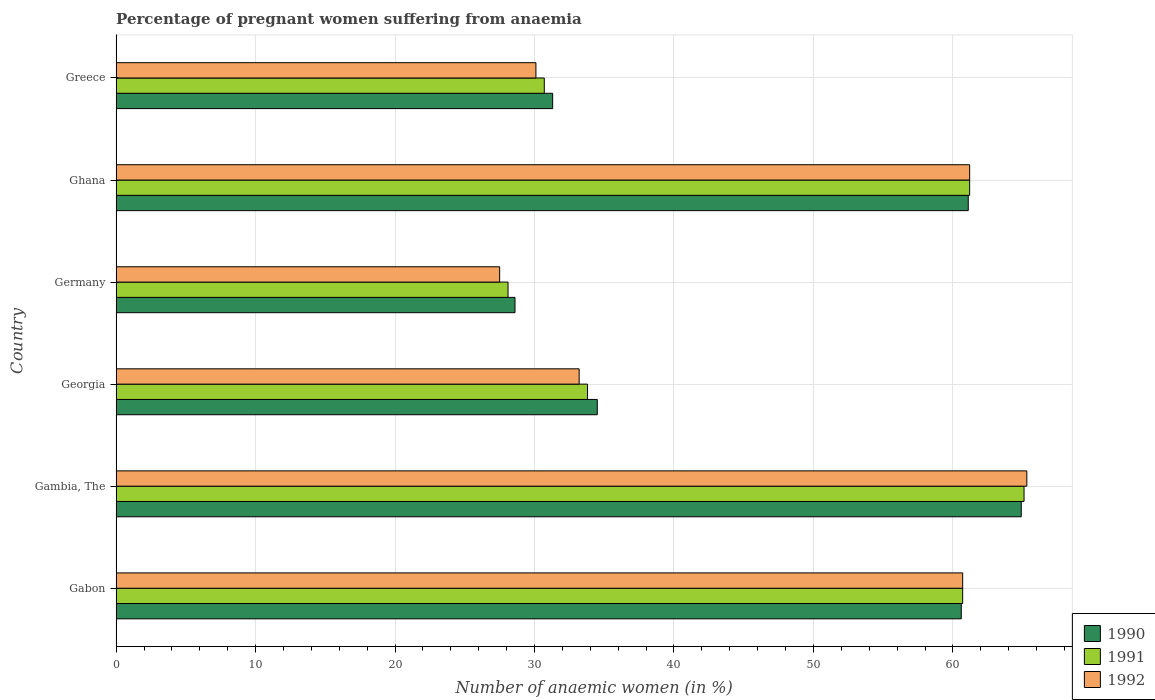Are the number of bars on each tick of the Y-axis equal?
Ensure brevity in your answer.  Yes. What is the label of the 1st group of bars from the top?
Provide a short and direct response. Greece. What is the number of anaemic women in 1991 in Georgia?
Keep it short and to the point. 33.8. Across all countries, what is the maximum number of anaemic women in 1991?
Offer a terse response. 65.1. In which country was the number of anaemic women in 1991 maximum?
Provide a short and direct response. Gambia, The. What is the total number of anaemic women in 1991 in the graph?
Your answer should be compact. 279.6. What is the difference between the number of anaemic women in 1991 in Germany and that in Ghana?
Ensure brevity in your answer.  -33.1. What is the difference between the number of anaemic women in 1992 in Greece and the number of anaemic women in 1991 in Gabon?
Offer a terse response. -30.6. What is the average number of anaemic women in 1991 per country?
Make the answer very short. 46.6. What is the difference between the number of anaemic women in 1992 and number of anaemic women in 1990 in Ghana?
Your answer should be very brief. 0.1. In how many countries, is the number of anaemic women in 1992 greater than 64 %?
Your response must be concise. 1. What is the ratio of the number of anaemic women in 1990 in Gambia, The to that in Greece?
Give a very brief answer. 2.07. Is the number of anaemic women in 1991 in Gabon less than that in Gambia, The?
Provide a succinct answer. Yes. Is the difference between the number of anaemic women in 1992 in Gambia, The and Georgia greater than the difference between the number of anaemic women in 1990 in Gambia, The and Georgia?
Your answer should be very brief. Yes. What is the difference between the highest and the second highest number of anaemic women in 1991?
Offer a very short reply. 3.9. What is the difference between the highest and the lowest number of anaemic women in 1992?
Keep it short and to the point. 37.8. How many bars are there?
Your response must be concise. 18. What is the difference between two consecutive major ticks on the X-axis?
Your response must be concise. 10. Does the graph contain any zero values?
Your answer should be very brief. No. How are the legend labels stacked?
Your answer should be very brief. Vertical. What is the title of the graph?
Give a very brief answer. Percentage of pregnant women suffering from anaemia. Does "1964" appear as one of the legend labels in the graph?
Give a very brief answer. No. What is the label or title of the X-axis?
Your answer should be very brief. Number of anaemic women (in %). What is the Number of anaemic women (in %) of 1990 in Gabon?
Your answer should be very brief. 60.6. What is the Number of anaemic women (in %) in 1991 in Gabon?
Make the answer very short. 60.7. What is the Number of anaemic women (in %) of 1992 in Gabon?
Provide a short and direct response. 60.7. What is the Number of anaemic women (in %) of 1990 in Gambia, The?
Your response must be concise. 64.9. What is the Number of anaemic women (in %) in 1991 in Gambia, The?
Offer a very short reply. 65.1. What is the Number of anaemic women (in %) of 1992 in Gambia, The?
Your response must be concise. 65.3. What is the Number of anaemic women (in %) of 1990 in Georgia?
Offer a terse response. 34.5. What is the Number of anaemic women (in %) of 1991 in Georgia?
Your answer should be compact. 33.8. What is the Number of anaemic women (in %) in 1992 in Georgia?
Provide a short and direct response. 33.2. What is the Number of anaemic women (in %) in 1990 in Germany?
Keep it short and to the point. 28.6. What is the Number of anaemic women (in %) of 1991 in Germany?
Offer a very short reply. 28.1. What is the Number of anaemic women (in %) in 1992 in Germany?
Make the answer very short. 27.5. What is the Number of anaemic women (in %) of 1990 in Ghana?
Give a very brief answer. 61.1. What is the Number of anaemic women (in %) of 1991 in Ghana?
Your answer should be very brief. 61.2. What is the Number of anaemic women (in %) in 1992 in Ghana?
Your answer should be compact. 61.2. What is the Number of anaemic women (in %) in 1990 in Greece?
Provide a succinct answer. 31.3. What is the Number of anaemic women (in %) of 1991 in Greece?
Keep it short and to the point. 30.7. What is the Number of anaemic women (in %) in 1992 in Greece?
Your answer should be very brief. 30.1. Across all countries, what is the maximum Number of anaemic women (in %) in 1990?
Your answer should be compact. 64.9. Across all countries, what is the maximum Number of anaemic women (in %) in 1991?
Offer a very short reply. 65.1. Across all countries, what is the maximum Number of anaemic women (in %) of 1992?
Offer a very short reply. 65.3. Across all countries, what is the minimum Number of anaemic women (in %) in 1990?
Keep it short and to the point. 28.6. Across all countries, what is the minimum Number of anaemic women (in %) in 1991?
Your answer should be compact. 28.1. What is the total Number of anaemic women (in %) of 1990 in the graph?
Give a very brief answer. 281. What is the total Number of anaemic women (in %) in 1991 in the graph?
Provide a short and direct response. 279.6. What is the total Number of anaemic women (in %) of 1992 in the graph?
Offer a very short reply. 278. What is the difference between the Number of anaemic women (in %) of 1991 in Gabon and that in Gambia, The?
Give a very brief answer. -4.4. What is the difference between the Number of anaemic women (in %) in 1990 in Gabon and that in Georgia?
Make the answer very short. 26.1. What is the difference between the Number of anaemic women (in %) in 1991 in Gabon and that in Georgia?
Offer a terse response. 26.9. What is the difference between the Number of anaemic women (in %) of 1992 in Gabon and that in Georgia?
Offer a very short reply. 27.5. What is the difference between the Number of anaemic women (in %) in 1990 in Gabon and that in Germany?
Provide a succinct answer. 32. What is the difference between the Number of anaemic women (in %) of 1991 in Gabon and that in Germany?
Your answer should be compact. 32.6. What is the difference between the Number of anaemic women (in %) of 1992 in Gabon and that in Germany?
Offer a terse response. 33.2. What is the difference between the Number of anaemic women (in %) in 1990 in Gabon and that in Ghana?
Your answer should be compact. -0.5. What is the difference between the Number of anaemic women (in %) of 1990 in Gabon and that in Greece?
Provide a short and direct response. 29.3. What is the difference between the Number of anaemic women (in %) of 1991 in Gabon and that in Greece?
Your response must be concise. 30. What is the difference between the Number of anaemic women (in %) of 1992 in Gabon and that in Greece?
Offer a terse response. 30.6. What is the difference between the Number of anaemic women (in %) in 1990 in Gambia, The and that in Georgia?
Make the answer very short. 30.4. What is the difference between the Number of anaemic women (in %) of 1991 in Gambia, The and that in Georgia?
Provide a succinct answer. 31.3. What is the difference between the Number of anaemic women (in %) in 1992 in Gambia, The and that in Georgia?
Keep it short and to the point. 32.1. What is the difference between the Number of anaemic women (in %) of 1990 in Gambia, The and that in Germany?
Your response must be concise. 36.3. What is the difference between the Number of anaemic women (in %) of 1992 in Gambia, The and that in Germany?
Provide a short and direct response. 37.8. What is the difference between the Number of anaemic women (in %) in 1990 in Gambia, The and that in Greece?
Give a very brief answer. 33.6. What is the difference between the Number of anaemic women (in %) in 1991 in Gambia, The and that in Greece?
Give a very brief answer. 34.4. What is the difference between the Number of anaemic women (in %) in 1992 in Gambia, The and that in Greece?
Your response must be concise. 35.2. What is the difference between the Number of anaemic women (in %) in 1990 in Georgia and that in Germany?
Give a very brief answer. 5.9. What is the difference between the Number of anaemic women (in %) of 1991 in Georgia and that in Germany?
Your answer should be very brief. 5.7. What is the difference between the Number of anaemic women (in %) in 1990 in Georgia and that in Ghana?
Your answer should be very brief. -26.6. What is the difference between the Number of anaemic women (in %) in 1991 in Georgia and that in Ghana?
Keep it short and to the point. -27.4. What is the difference between the Number of anaemic women (in %) of 1991 in Georgia and that in Greece?
Your answer should be very brief. 3.1. What is the difference between the Number of anaemic women (in %) in 1990 in Germany and that in Ghana?
Ensure brevity in your answer.  -32.5. What is the difference between the Number of anaemic women (in %) in 1991 in Germany and that in Ghana?
Make the answer very short. -33.1. What is the difference between the Number of anaemic women (in %) of 1992 in Germany and that in Ghana?
Give a very brief answer. -33.7. What is the difference between the Number of anaemic women (in %) in 1990 in Germany and that in Greece?
Give a very brief answer. -2.7. What is the difference between the Number of anaemic women (in %) of 1992 in Germany and that in Greece?
Provide a succinct answer. -2.6. What is the difference between the Number of anaemic women (in %) in 1990 in Ghana and that in Greece?
Keep it short and to the point. 29.8. What is the difference between the Number of anaemic women (in %) of 1991 in Ghana and that in Greece?
Make the answer very short. 30.5. What is the difference between the Number of anaemic women (in %) of 1992 in Ghana and that in Greece?
Your response must be concise. 31.1. What is the difference between the Number of anaemic women (in %) of 1990 in Gabon and the Number of anaemic women (in %) of 1992 in Gambia, The?
Give a very brief answer. -4.7. What is the difference between the Number of anaemic women (in %) of 1991 in Gabon and the Number of anaemic women (in %) of 1992 in Gambia, The?
Keep it short and to the point. -4.6. What is the difference between the Number of anaemic women (in %) of 1990 in Gabon and the Number of anaemic women (in %) of 1991 in Georgia?
Offer a terse response. 26.8. What is the difference between the Number of anaemic women (in %) of 1990 in Gabon and the Number of anaemic women (in %) of 1992 in Georgia?
Your answer should be very brief. 27.4. What is the difference between the Number of anaemic women (in %) of 1990 in Gabon and the Number of anaemic women (in %) of 1991 in Germany?
Provide a succinct answer. 32.5. What is the difference between the Number of anaemic women (in %) in 1990 in Gabon and the Number of anaemic women (in %) in 1992 in Germany?
Provide a short and direct response. 33.1. What is the difference between the Number of anaemic women (in %) in 1991 in Gabon and the Number of anaemic women (in %) in 1992 in Germany?
Provide a short and direct response. 33.2. What is the difference between the Number of anaemic women (in %) in 1990 in Gabon and the Number of anaemic women (in %) in 1991 in Greece?
Keep it short and to the point. 29.9. What is the difference between the Number of anaemic women (in %) in 1990 in Gabon and the Number of anaemic women (in %) in 1992 in Greece?
Give a very brief answer. 30.5. What is the difference between the Number of anaemic women (in %) in 1991 in Gabon and the Number of anaemic women (in %) in 1992 in Greece?
Offer a very short reply. 30.6. What is the difference between the Number of anaemic women (in %) in 1990 in Gambia, The and the Number of anaemic women (in %) in 1991 in Georgia?
Provide a short and direct response. 31.1. What is the difference between the Number of anaemic women (in %) of 1990 in Gambia, The and the Number of anaemic women (in %) of 1992 in Georgia?
Provide a succinct answer. 31.7. What is the difference between the Number of anaemic women (in %) of 1991 in Gambia, The and the Number of anaemic women (in %) of 1992 in Georgia?
Keep it short and to the point. 31.9. What is the difference between the Number of anaemic women (in %) of 1990 in Gambia, The and the Number of anaemic women (in %) of 1991 in Germany?
Your answer should be compact. 36.8. What is the difference between the Number of anaemic women (in %) of 1990 in Gambia, The and the Number of anaemic women (in %) of 1992 in Germany?
Offer a very short reply. 37.4. What is the difference between the Number of anaemic women (in %) of 1991 in Gambia, The and the Number of anaemic women (in %) of 1992 in Germany?
Make the answer very short. 37.6. What is the difference between the Number of anaemic women (in %) in 1990 in Gambia, The and the Number of anaemic women (in %) in 1992 in Ghana?
Provide a short and direct response. 3.7. What is the difference between the Number of anaemic women (in %) in 1990 in Gambia, The and the Number of anaemic women (in %) in 1991 in Greece?
Keep it short and to the point. 34.2. What is the difference between the Number of anaemic women (in %) of 1990 in Gambia, The and the Number of anaemic women (in %) of 1992 in Greece?
Offer a very short reply. 34.8. What is the difference between the Number of anaemic women (in %) of 1990 in Georgia and the Number of anaemic women (in %) of 1991 in Germany?
Offer a terse response. 6.4. What is the difference between the Number of anaemic women (in %) of 1990 in Georgia and the Number of anaemic women (in %) of 1991 in Ghana?
Offer a very short reply. -26.7. What is the difference between the Number of anaemic women (in %) in 1990 in Georgia and the Number of anaemic women (in %) in 1992 in Ghana?
Provide a succinct answer. -26.7. What is the difference between the Number of anaemic women (in %) of 1991 in Georgia and the Number of anaemic women (in %) of 1992 in Ghana?
Give a very brief answer. -27.4. What is the difference between the Number of anaemic women (in %) of 1990 in Georgia and the Number of anaemic women (in %) of 1991 in Greece?
Keep it short and to the point. 3.8. What is the difference between the Number of anaemic women (in %) of 1990 in Georgia and the Number of anaemic women (in %) of 1992 in Greece?
Your answer should be very brief. 4.4. What is the difference between the Number of anaemic women (in %) of 1990 in Germany and the Number of anaemic women (in %) of 1991 in Ghana?
Offer a very short reply. -32.6. What is the difference between the Number of anaemic women (in %) in 1990 in Germany and the Number of anaemic women (in %) in 1992 in Ghana?
Your answer should be compact. -32.6. What is the difference between the Number of anaemic women (in %) of 1991 in Germany and the Number of anaemic women (in %) of 1992 in Ghana?
Your response must be concise. -33.1. What is the difference between the Number of anaemic women (in %) in 1991 in Germany and the Number of anaemic women (in %) in 1992 in Greece?
Your response must be concise. -2. What is the difference between the Number of anaemic women (in %) of 1990 in Ghana and the Number of anaemic women (in %) of 1991 in Greece?
Offer a terse response. 30.4. What is the difference between the Number of anaemic women (in %) in 1991 in Ghana and the Number of anaemic women (in %) in 1992 in Greece?
Provide a short and direct response. 31.1. What is the average Number of anaemic women (in %) in 1990 per country?
Your response must be concise. 46.83. What is the average Number of anaemic women (in %) of 1991 per country?
Offer a very short reply. 46.6. What is the average Number of anaemic women (in %) of 1992 per country?
Give a very brief answer. 46.33. What is the difference between the Number of anaemic women (in %) in 1990 and Number of anaemic women (in %) in 1991 in Gabon?
Your response must be concise. -0.1. What is the difference between the Number of anaemic women (in %) of 1990 and Number of anaemic women (in %) of 1991 in Gambia, The?
Give a very brief answer. -0.2. What is the difference between the Number of anaemic women (in %) of 1990 and Number of anaemic women (in %) of 1992 in Gambia, The?
Offer a very short reply. -0.4. What is the difference between the Number of anaemic women (in %) of 1990 and Number of anaemic women (in %) of 1992 in Georgia?
Offer a terse response. 1.3. What is the difference between the Number of anaemic women (in %) of 1991 and Number of anaemic women (in %) of 1992 in Georgia?
Provide a succinct answer. 0.6. What is the difference between the Number of anaemic women (in %) in 1990 and Number of anaemic women (in %) in 1991 in Germany?
Make the answer very short. 0.5. What is the difference between the Number of anaemic women (in %) in 1991 and Number of anaemic women (in %) in 1992 in Germany?
Offer a very short reply. 0.6. What is the difference between the Number of anaemic women (in %) in 1990 and Number of anaemic women (in %) in 1992 in Ghana?
Keep it short and to the point. -0.1. What is the difference between the Number of anaemic women (in %) of 1991 and Number of anaemic women (in %) of 1992 in Ghana?
Offer a terse response. 0. What is the difference between the Number of anaemic women (in %) in 1990 and Number of anaemic women (in %) in 1991 in Greece?
Give a very brief answer. 0.6. What is the difference between the Number of anaemic women (in %) of 1991 and Number of anaemic women (in %) of 1992 in Greece?
Your response must be concise. 0.6. What is the ratio of the Number of anaemic women (in %) in 1990 in Gabon to that in Gambia, The?
Offer a very short reply. 0.93. What is the ratio of the Number of anaemic women (in %) in 1991 in Gabon to that in Gambia, The?
Offer a very short reply. 0.93. What is the ratio of the Number of anaemic women (in %) of 1992 in Gabon to that in Gambia, The?
Ensure brevity in your answer.  0.93. What is the ratio of the Number of anaemic women (in %) in 1990 in Gabon to that in Georgia?
Your answer should be compact. 1.76. What is the ratio of the Number of anaemic women (in %) of 1991 in Gabon to that in Georgia?
Your answer should be very brief. 1.8. What is the ratio of the Number of anaemic women (in %) in 1992 in Gabon to that in Georgia?
Provide a short and direct response. 1.83. What is the ratio of the Number of anaemic women (in %) in 1990 in Gabon to that in Germany?
Offer a terse response. 2.12. What is the ratio of the Number of anaemic women (in %) in 1991 in Gabon to that in Germany?
Give a very brief answer. 2.16. What is the ratio of the Number of anaemic women (in %) of 1992 in Gabon to that in Germany?
Your response must be concise. 2.21. What is the ratio of the Number of anaemic women (in %) of 1991 in Gabon to that in Ghana?
Ensure brevity in your answer.  0.99. What is the ratio of the Number of anaemic women (in %) in 1990 in Gabon to that in Greece?
Your response must be concise. 1.94. What is the ratio of the Number of anaemic women (in %) in 1991 in Gabon to that in Greece?
Provide a short and direct response. 1.98. What is the ratio of the Number of anaemic women (in %) in 1992 in Gabon to that in Greece?
Provide a succinct answer. 2.02. What is the ratio of the Number of anaemic women (in %) in 1990 in Gambia, The to that in Georgia?
Your answer should be compact. 1.88. What is the ratio of the Number of anaemic women (in %) in 1991 in Gambia, The to that in Georgia?
Offer a very short reply. 1.93. What is the ratio of the Number of anaemic women (in %) of 1992 in Gambia, The to that in Georgia?
Offer a terse response. 1.97. What is the ratio of the Number of anaemic women (in %) in 1990 in Gambia, The to that in Germany?
Make the answer very short. 2.27. What is the ratio of the Number of anaemic women (in %) of 1991 in Gambia, The to that in Germany?
Ensure brevity in your answer.  2.32. What is the ratio of the Number of anaemic women (in %) in 1992 in Gambia, The to that in Germany?
Offer a very short reply. 2.37. What is the ratio of the Number of anaemic women (in %) in 1990 in Gambia, The to that in Ghana?
Provide a short and direct response. 1.06. What is the ratio of the Number of anaemic women (in %) in 1991 in Gambia, The to that in Ghana?
Offer a very short reply. 1.06. What is the ratio of the Number of anaemic women (in %) of 1992 in Gambia, The to that in Ghana?
Provide a succinct answer. 1.07. What is the ratio of the Number of anaemic women (in %) in 1990 in Gambia, The to that in Greece?
Your answer should be very brief. 2.07. What is the ratio of the Number of anaemic women (in %) in 1991 in Gambia, The to that in Greece?
Offer a terse response. 2.12. What is the ratio of the Number of anaemic women (in %) of 1992 in Gambia, The to that in Greece?
Your response must be concise. 2.17. What is the ratio of the Number of anaemic women (in %) of 1990 in Georgia to that in Germany?
Offer a very short reply. 1.21. What is the ratio of the Number of anaemic women (in %) in 1991 in Georgia to that in Germany?
Your answer should be compact. 1.2. What is the ratio of the Number of anaemic women (in %) of 1992 in Georgia to that in Germany?
Give a very brief answer. 1.21. What is the ratio of the Number of anaemic women (in %) of 1990 in Georgia to that in Ghana?
Provide a short and direct response. 0.56. What is the ratio of the Number of anaemic women (in %) in 1991 in Georgia to that in Ghana?
Offer a terse response. 0.55. What is the ratio of the Number of anaemic women (in %) of 1992 in Georgia to that in Ghana?
Make the answer very short. 0.54. What is the ratio of the Number of anaemic women (in %) in 1990 in Georgia to that in Greece?
Make the answer very short. 1.1. What is the ratio of the Number of anaemic women (in %) in 1991 in Georgia to that in Greece?
Your answer should be compact. 1.1. What is the ratio of the Number of anaemic women (in %) in 1992 in Georgia to that in Greece?
Offer a terse response. 1.1. What is the ratio of the Number of anaemic women (in %) in 1990 in Germany to that in Ghana?
Offer a very short reply. 0.47. What is the ratio of the Number of anaemic women (in %) in 1991 in Germany to that in Ghana?
Provide a succinct answer. 0.46. What is the ratio of the Number of anaemic women (in %) in 1992 in Germany to that in Ghana?
Your answer should be compact. 0.45. What is the ratio of the Number of anaemic women (in %) of 1990 in Germany to that in Greece?
Make the answer very short. 0.91. What is the ratio of the Number of anaemic women (in %) in 1991 in Germany to that in Greece?
Your answer should be compact. 0.92. What is the ratio of the Number of anaemic women (in %) of 1992 in Germany to that in Greece?
Your answer should be very brief. 0.91. What is the ratio of the Number of anaemic women (in %) in 1990 in Ghana to that in Greece?
Offer a terse response. 1.95. What is the ratio of the Number of anaemic women (in %) of 1991 in Ghana to that in Greece?
Your response must be concise. 1.99. What is the ratio of the Number of anaemic women (in %) in 1992 in Ghana to that in Greece?
Your answer should be compact. 2.03. What is the difference between the highest and the second highest Number of anaemic women (in %) in 1991?
Keep it short and to the point. 3.9. What is the difference between the highest and the lowest Number of anaemic women (in %) of 1990?
Keep it short and to the point. 36.3. What is the difference between the highest and the lowest Number of anaemic women (in %) of 1992?
Provide a short and direct response. 37.8. 